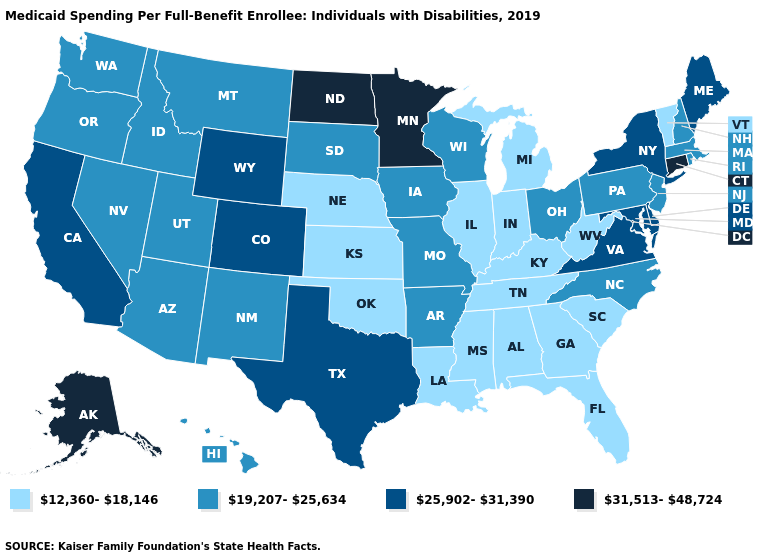Name the states that have a value in the range 12,360-18,146?
Concise answer only. Alabama, Florida, Georgia, Illinois, Indiana, Kansas, Kentucky, Louisiana, Michigan, Mississippi, Nebraska, Oklahoma, South Carolina, Tennessee, Vermont, West Virginia. Is the legend a continuous bar?
Be succinct. No. Name the states that have a value in the range 25,902-31,390?
Answer briefly. California, Colorado, Delaware, Maine, Maryland, New York, Texas, Virginia, Wyoming. Which states have the lowest value in the MidWest?
Concise answer only. Illinois, Indiana, Kansas, Michigan, Nebraska. How many symbols are there in the legend?
Short answer required. 4. What is the highest value in states that border Rhode Island?
Be succinct. 31,513-48,724. Does the map have missing data?
Keep it brief. No. What is the highest value in the South ?
Short answer required. 25,902-31,390. What is the value of Connecticut?
Concise answer only. 31,513-48,724. Which states have the lowest value in the USA?
Keep it brief. Alabama, Florida, Georgia, Illinois, Indiana, Kansas, Kentucky, Louisiana, Michigan, Mississippi, Nebraska, Oklahoma, South Carolina, Tennessee, Vermont, West Virginia. What is the highest value in the USA?
Short answer required. 31,513-48,724. What is the highest value in states that border Mississippi?
Quick response, please. 19,207-25,634. How many symbols are there in the legend?
Keep it brief. 4. Does Maryland have the lowest value in the USA?
Give a very brief answer. No. Does the map have missing data?
Write a very short answer. No. 